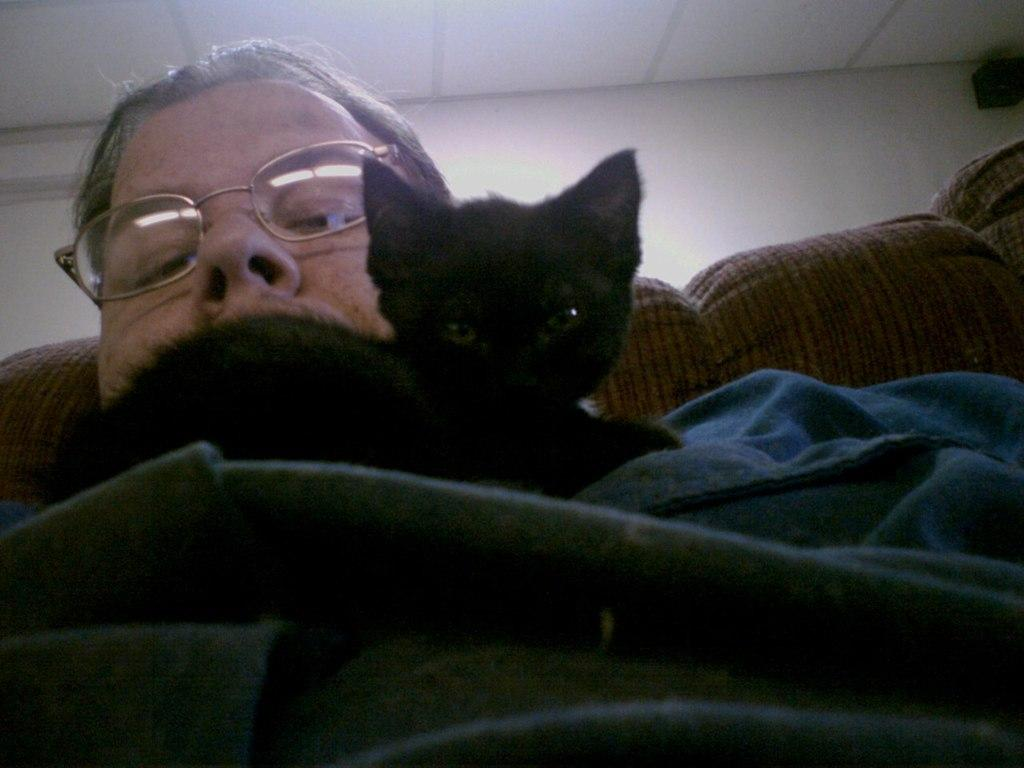Who is present in the image? There is a man in the image. What is the man doing in the image? The man is sitting on a couch. What is the man holding in the image? The man is holding a cat. Where is the cat located in the image? The cat is on a bed sheet. What can be seen in the background of the image? There is a wall visible in the background of the image. What type of doctor is attending to the man in the image? There is no doctor present in the image; it features a man holding a cat on a bed sheet. What is the aftermath of the airplane crash in the image? There is no airplane crash or aftermath depicted in the image; it shows a man holding a cat on a bed sheet. 